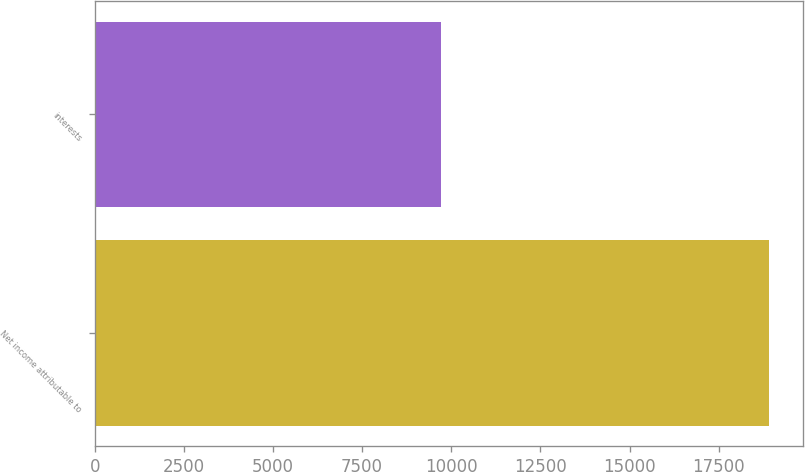<chart> <loc_0><loc_0><loc_500><loc_500><bar_chart><fcel>Net income attributable to<fcel>interests<nl><fcel>18918<fcel>9717<nl></chart> 